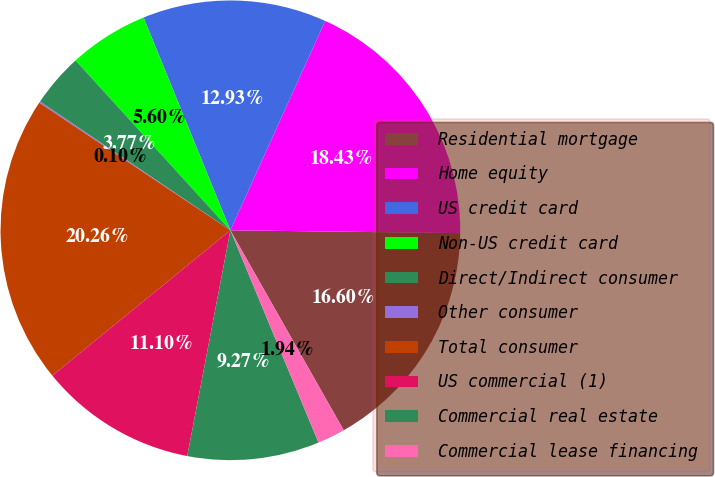Convert chart. <chart><loc_0><loc_0><loc_500><loc_500><pie_chart><fcel>Residential mortgage<fcel>Home equity<fcel>US credit card<fcel>Non-US credit card<fcel>Direct/Indirect consumer<fcel>Other consumer<fcel>Total consumer<fcel>US commercial (1)<fcel>Commercial real estate<fcel>Commercial lease financing<nl><fcel>16.6%<fcel>18.43%<fcel>12.93%<fcel>5.6%<fcel>3.77%<fcel>0.1%<fcel>20.26%<fcel>11.1%<fcel>9.27%<fcel>1.94%<nl></chart> 